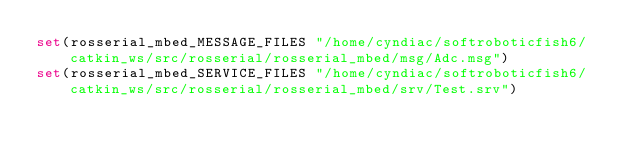<code> <loc_0><loc_0><loc_500><loc_500><_CMake_>set(rosserial_mbed_MESSAGE_FILES "/home/cyndiac/softroboticfish6/catkin_ws/src/rosserial/rosserial_mbed/msg/Adc.msg")
set(rosserial_mbed_SERVICE_FILES "/home/cyndiac/softroboticfish6/catkin_ws/src/rosserial/rosserial_mbed/srv/Test.srv")
</code> 